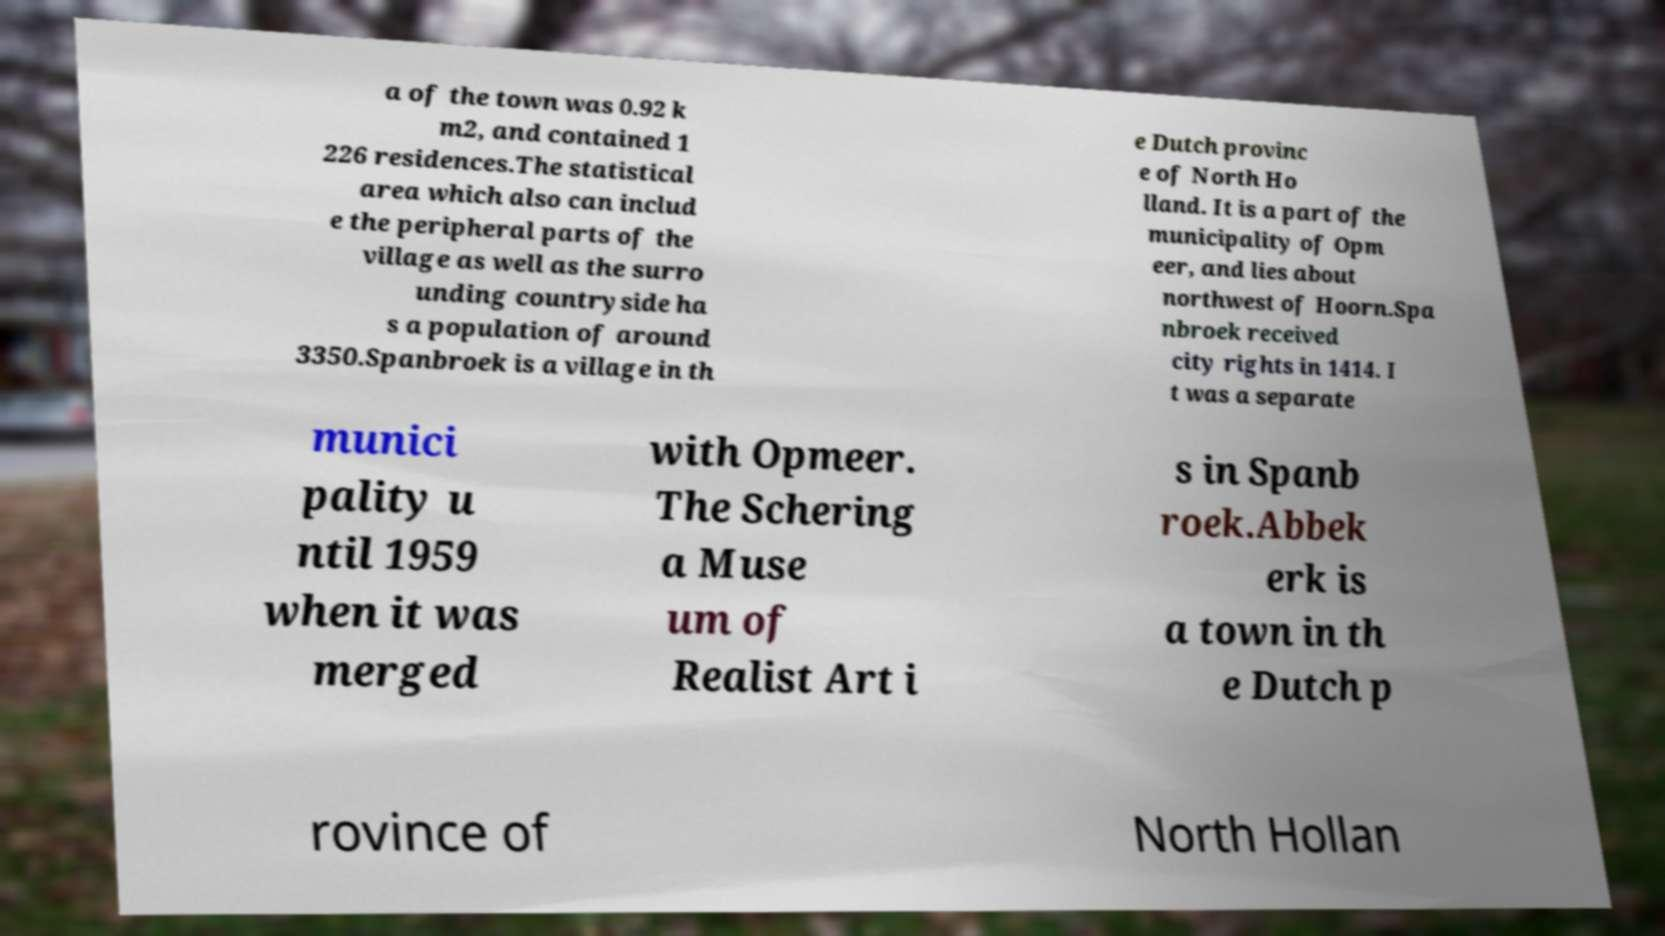Could you extract and type out the text from this image? a of the town was 0.92 k m2, and contained 1 226 residences.The statistical area which also can includ e the peripheral parts of the village as well as the surro unding countryside ha s a population of around 3350.Spanbroek is a village in th e Dutch provinc e of North Ho lland. It is a part of the municipality of Opm eer, and lies about northwest of Hoorn.Spa nbroek received city rights in 1414. I t was a separate munici pality u ntil 1959 when it was merged with Opmeer. The Schering a Muse um of Realist Art i s in Spanb roek.Abbek erk is a town in th e Dutch p rovince of North Hollan 